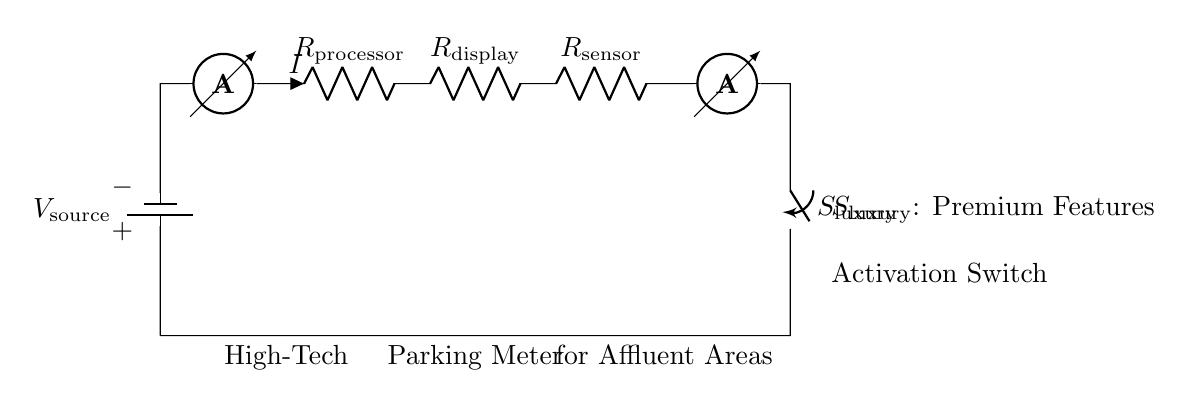What is the power source for the circuit? The circuit uses a battery as the source of power, indicated by the symbol for the battery at the top left.
Answer: Battery What are the resistors in this circuit? The circuit contains three resistors labeled as the processor, display, and sensor, clearly indicated in the diagram with their respective labels.
Answer: Processor, Display, Sensor What is the purpose of the ammeters in the circuit? The ammeters measure the current flowing through different parts of the circuit, located before and after the resistors for monitoring the flow of electricity.
Answer: Measure current What happens when the luxury switch is activated? Activating the luxury switch may enable premium features of the high-tech parking meter, which suggests additional functions can be controlled by that switch.
Answer: Enables premium features How do the resistors affect the total current in the circuit? In a series circuit, the total resistance is the sum of all resistances, which reduces the overall current according to Ohm’s Law, meaning that all components share the same current but divide the total voltage.
Answer: Reduces current What is the role of the voltage source in this circuit? The voltage source provides the necessary electrical energy to drive the circuit, establishing the potential difference required for current to flow through all circuit components.
Answer: Provides electrical energy What type of circuit configuration is being used here? The circuit is configured as a series circuit, indicated by the arrangement of components connected end-to-end, where the same current passes through each element sequentially.
Answer: Series circuit 